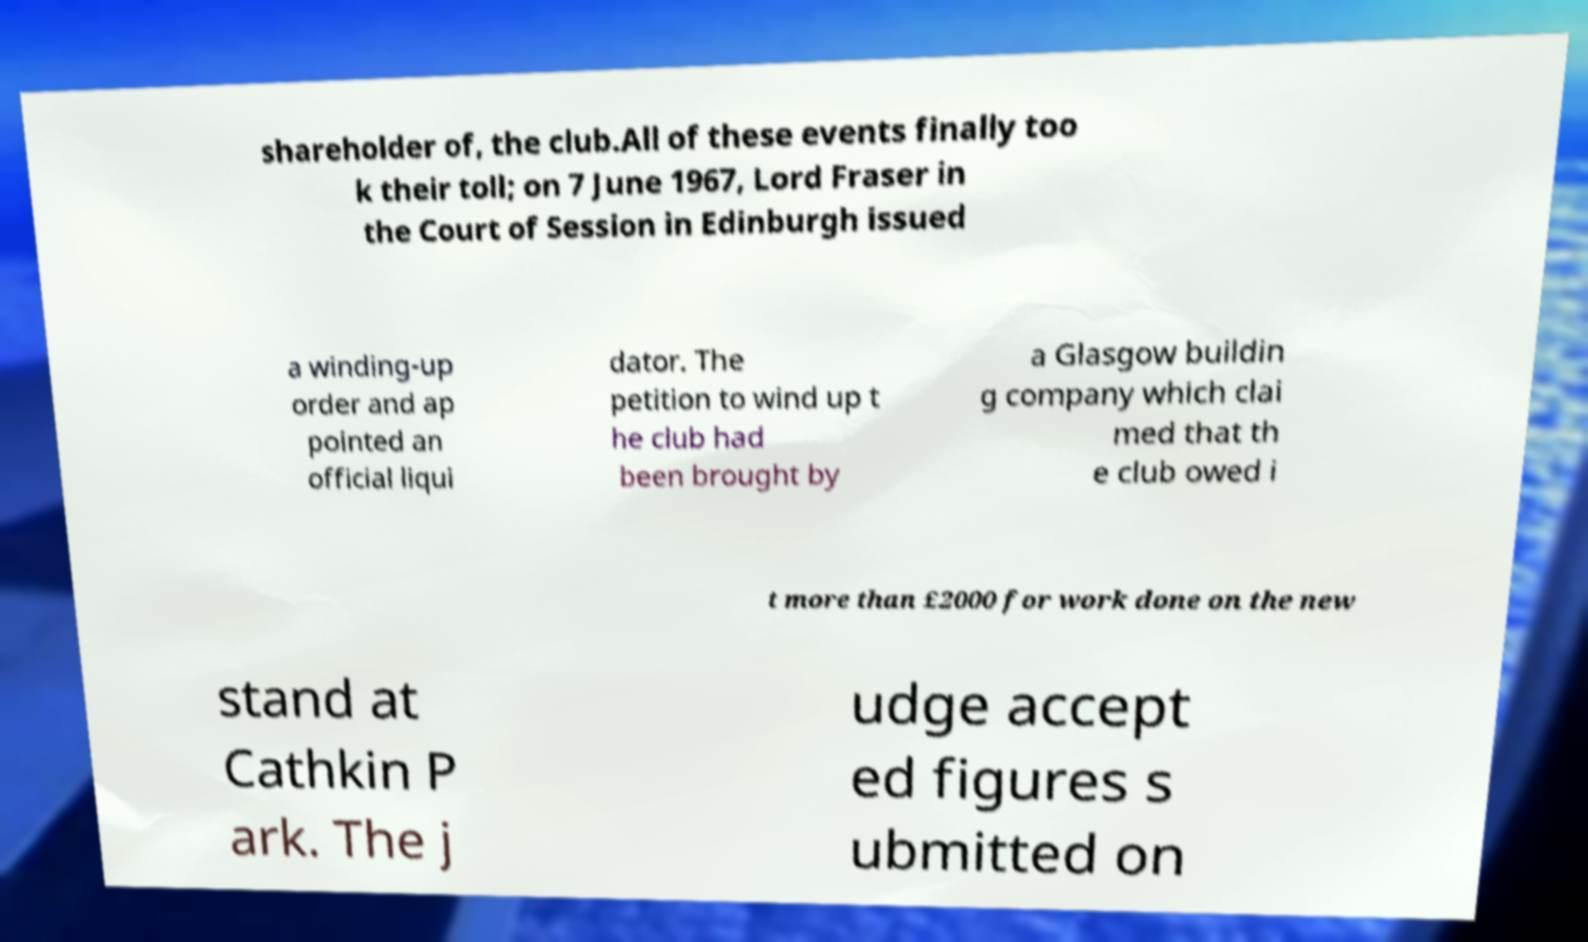Can you read and provide the text displayed in the image?This photo seems to have some interesting text. Can you extract and type it out for me? shareholder of, the club.All of these events finally too k their toll; on 7 June 1967, Lord Fraser in the Court of Session in Edinburgh issued a winding-up order and ap pointed an official liqui dator. The petition to wind up t he club had been brought by a Glasgow buildin g company which clai med that th e club owed i t more than £2000 for work done on the new stand at Cathkin P ark. The j udge accept ed figures s ubmitted on 